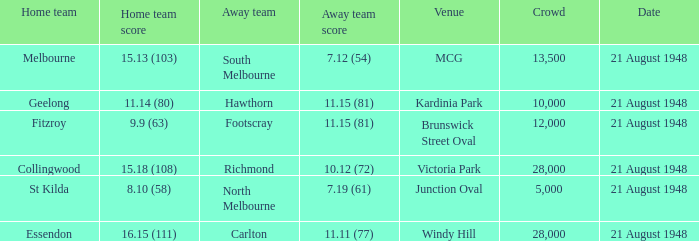If there are more than 10,000 spectators and the away team has a score of 11.15 (81), at which venue is the game being played? Brunswick Street Oval. 